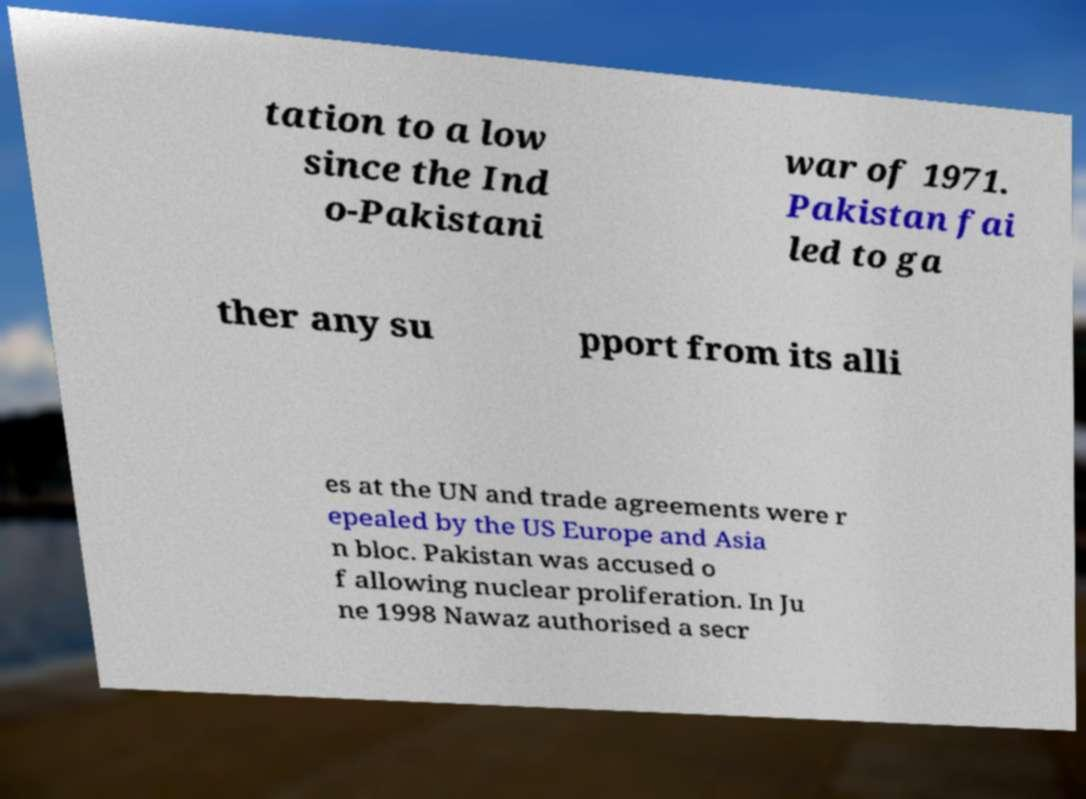For documentation purposes, I need the text within this image transcribed. Could you provide that? tation to a low since the Ind o-Pakistani war of 1971. Pakistan fai led to ga ther any su pport from its alli es at the UN and trade agreements were r epealed by the US Europe and Asia n bloc. Pakistan was accused o f allowing nuclear proliferation. In Ju ne 1998 Nawaz authorised a secr 